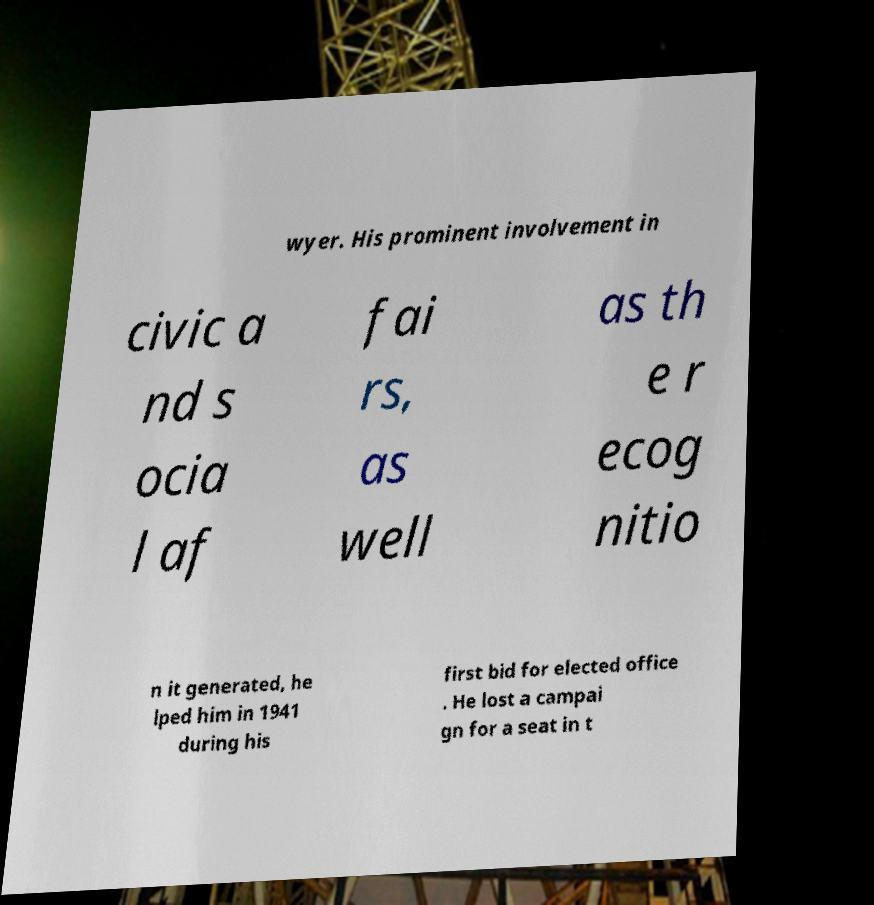Could you extract and type out the text from this image? wyer. His prominent involvement in civic a nd s ocia l af fai rs, as well as th e r ecog nitio n it generated, he lped him in 1941 during his first bid for elected office . He lost a campai gn for a seat in t 